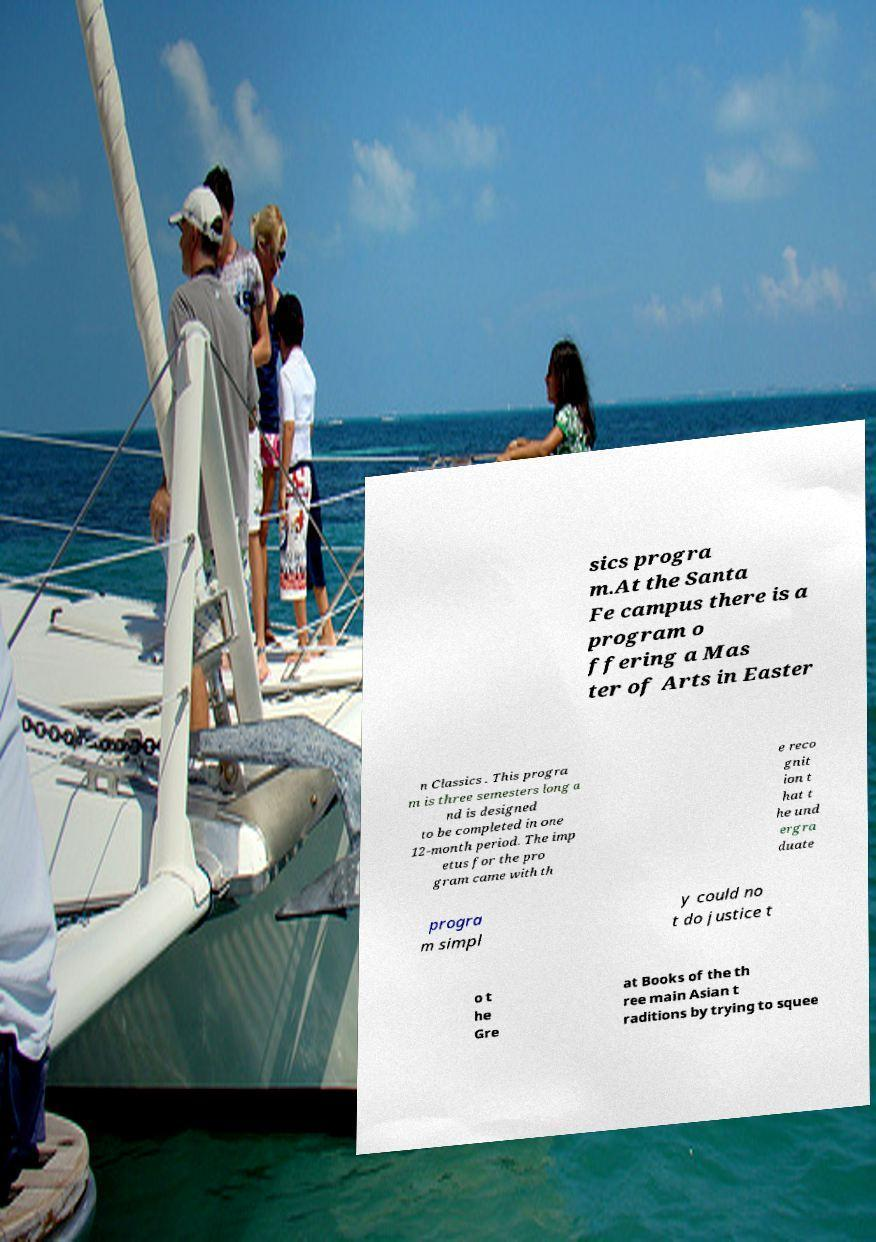Please read and relay the text visible in this image. What does it say? sics progra m.At the Santa Fe campus there is a program o ffering a Mas ter of Arts in Easter n Classics . This progra m is three semesters long a nd is designed to be completed in one 12-month period. The imp etus for the pro gram came with th e reco gnit ion t hat t he und ergra duate progra m simpl y could no t do justice t o t he Gre at Books of the th ree main Asian t raditions by trying to squee 